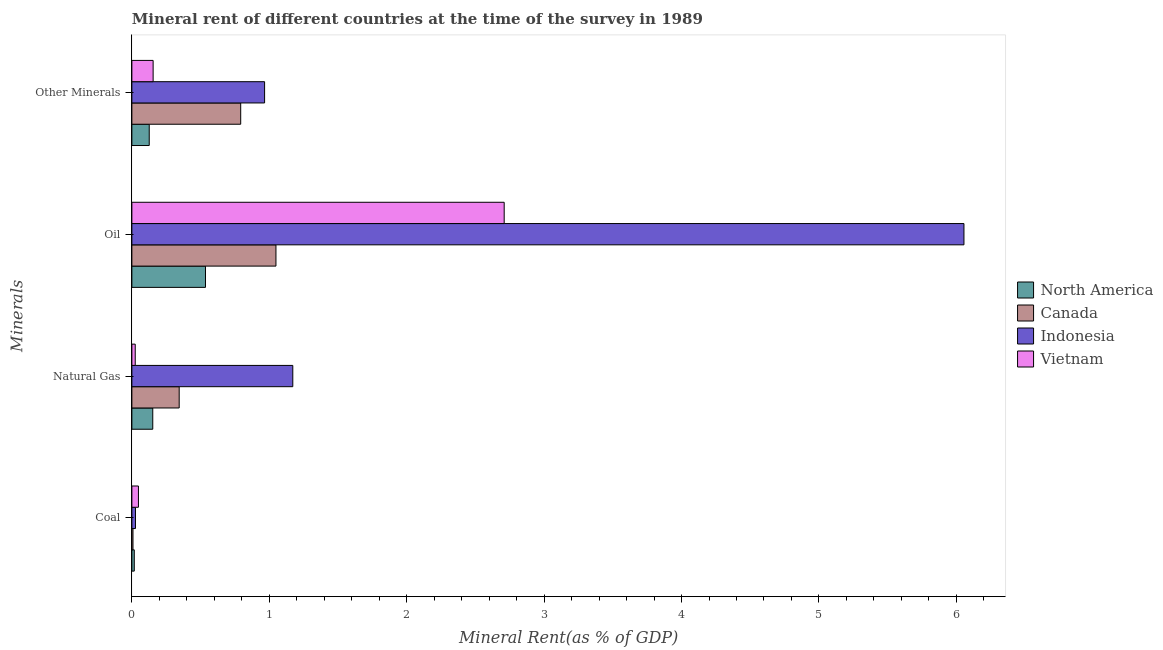Are the number of bars on each tick of the Y-axis equal?
Offer a very short reply. Yes. What is the label of the 2nd group of bars from the top?
Make the answer very short. Oil. What is the natural gas rent in Vietnam?
Provide a short and direct response. 0.02. Across all countries, what is the maximum  rent of other minerals?
Provide a short and direct response. 0.97. Across all countries, what is the minimum oil rent?
Provide a short and direct response. 0.54. What is the total coal rent in the graph?
Keep it short and to the point. 0.1. What is the difference between the  rent of other minerals in Canada and that in North America?
Your response must be concise. 0.67. What is the difference between the natural gas rent in Canada and the coal rent in Indonesia?
Make the answer very short. 0.32. What is the average coal rent per country?
Provide a short and direct response. 0.02. What is the difference between the  rent of other minerals and coal rent in Vietnam?
Provide a succinct answer. 0.11. In how many countries, is the  rent of other minerals greater than 0.6000000000000001 %?
Offer a terse response. 2. What is the ratio of the  rent of other minerals in Indonesia to that in North America?
Provide a succinct answer. 7.64. What is the difference between the highest and the second highest  rent of other minerals?
Offer a very short reply. 0.17. What is the difference between the highest and the lowest natural gas rent?
Provide a succinct answer. 1.15. In how many countries, is the coal rent greater than the average coal rent taken over all countries?
Provide a short and direct response. 2. Is the sum of the natural gas rent in Vietnam and Canada greater than the maximum coal rent across all countries?
Offer a very short reply. Yes. Is it the case that in every country, the sum of the oil rent and natural gas rent is greater than the sum of coal rent and  rent of other minerals?
Offer a very short reply. Yes. What does the 4th bar from the bottom in Natural Gas represents?
Ensure brevity in your answer.  Vietnam. How many bars are there?
Your response must be concise. 16. Are all the bars in the graph horizontal?
Provide a short and direct response. Yes. What is the difference between two consecutive major ticks on the X-axis?
Your answer should be very brief. 1. Does the graph contain grids?
Ensure brevity in your answer.  No. What is the title of the graph?
Give a very brief answer. Mineral rent of different countries at the time of the survey in 1989. What is the label or title of the X-axis?
Provide a short and direct response. Mineral Rent(as % of GDP). What is the label or title of the Y-axis?
Keep it short and to the point. Minerals. What is the Mineral Rent(as % of GDP) of North America in Coal?
Provide a short and direct response. 0.02. What is the Mineral Rent(as % of GDP) of Canada in Coal?
Provide a succinct answer. 0.01. What is the Mineral Rent(as % of GDP) in Indonesia in Coal?
Provide a short and direct response. 0.03. What is the Mineral Rent(as % of GDP) in Vietnam in Coal?
Give a very brief answer. 0.05. What is the Mineral Rent(as % of GDP) in North America in Natural Gas?
Give a very brief answer. 0.15. What is the Mineral Rent(as % of GDP) in Canada in Natural Gas?
Provide a short and direct response. 0.34. What is the Mineral Rent(as % of GDP) of Indonesia in Natural Gas?
Make the answer very short. 1.17. What is the Mineral Rent(as % of GDP) of Vietnam in Natural Gas?
Provide a short and direct response. 0.02. What is the Mineral Rent(as % of GDP) of North America in Oil?
Give a very brief answer. 0.54. What is the Mineral Rent(as % of GDP) in Canada in Oil?
Your answer should be compact. 1.05. What is the Mineral Rent(as % of GDP) in Indonesia in Oil?
Your answer should be very brief. 6.06. What is the Mineral Rent(as % of GDP) in Vietnam in Oil?
Provide a short and direct response. 2.71. What is the Mineral Rent(as % of GDP) of North America in Other Minerals?
Your response must be concise. 0.13. What is the Mineral Rent(as % of GDP) in Canada in Other Minerals?
Provide a succinct answer. 0.79. What is the Mineral Rent(as % of GDP) in Indonesia in Other Minerals?
Offer a terse response. 0.97. What is the Mineral Rent(as % of GDP) in Vietnam in Other Minerals?
Ensure brevity in your answer.  0.15. Across all Minerals, what is the maximum Mineral Rent(as % of GDP) in North America?
Ensure brevity in your answer.  0.54. Across all Minerals, what is the maximum Mineral Rent(as % of GDP) in Canada?
Your response must be concise. 1.05. Across all Minerals, what is the maximum Mineral Rent(as % of GDP) in Indonesia?
Your answer should be very brief. 6.06. Across all Minerals, what is the maximum Mineral Rent(as % of GDP) of Vietnam?
Make the answer very short. 2.71. Across all Minerals, what is the minimum Mineral Rent(as % of GDP) in North America?
Ensure brevity in your answer.  0.02. Across all Minerals, what is the minimum Mineral Rent(as % of GDP) of Canada?
Provide a succinct answer. 0.01. Across all Minerals, what is the minimum Mineral Rent(as % of GDP) of Indonesia?
Provide a succinct answer. 0.03. Across all Minerals, what is the minimum Mineral Rent(as % of GDP) in Vietnam?
Offer a terse response. 0.02. What is the total Mineral Rent(as % of GDP) of North America in the graph?
Offer a very short reply. 0.83. What is the total Mineral Rent(as % of GDP) in Canada in the graph?
Provide a succinct answer. 2.19. What is the total Mineral Rent(as % of GDP) of Indonesia in the graph?
Offer a terse response. 8.22. What is the total Mineral Rent(as % of GDP) in Vietnam in the graph?
Provide a short and direct response. 2.94. What is the difference between the Mineral Rent(as % of GDP) of North America in Coal and that in Natural Gas?
Your answer should be very brief. -0.13. What is the difference between the Mineral Rent(as % of GDP) of Canada in Coal and that in Natural Gas?
Ensure brevity in your answer.  -0.34. What is the difference between the Mineral Rent(as % of GDP) of Indonesia in Coal and that in Natural Gas?
Make the answer very short. -1.14. What is the difference between the Mineral Rent(as % of GDP) of Vietnam in Coal and that in Natural Gas?
Your answer should be very brief. 0.02. What is the difference between the Mineral Rent(as % of GDP) in North America in Coal and that in Oil?
Provide a short and direct response. -0.52. What is the difference between the Mineral Rent(as % of GDP) in Canada in Coal and that in Oil?
Offer a very short reply. -1.04. What is the difference between the Mineral Rent(as % of GDP) of Indonesia in Coal and that in Oil?
Offer a very short reply. -6.03. What is the difference between the Mineral Rent(as % of GDP) in Vietnam in Coal and that in Oil?
Your answer should be compact. -2.66. What is the difference between the Mineral Rent(as % of GDP) in North America in Coal and that in Other Minerals?
Provide a succinct answer. -0.11. What is the difference between the Mineral Rent(as % of GDP) of Canada in Coal and that in Other Minerals?
Give a very brief answer. -0.78. What is the difference between the Mineral Rent(as % of GDP) of Indonesia in Coal and that in Other Minerals?
Keep it short and to the point. -0.94. What is the difference between the Mineral Rent(as % of GDP) in Vietnam in Coal and that in Other Minerals?
Your answer should be very brief. -0.11. What is the difference between the Mineral Rent(as % of GDP) of North America in Natural Gas and that in Oil?
Make the answer very short. -0.38. What is the difference between the Mineral Rent(as % of GDP) of Canada in Natural Gas and that in Oil?
Your answer should be compact. -0.7. What is the difference between the Mineral Rent(as % of GDP) in Indonesia in Natural Gas and that in Oil?
Give a very brief answer. -4.88. What is the difference between the Mineral Rent(as % of GDP) in Vietnam in Natural Gas and that in Oil?
Provide a succinct answer. -2.69. What is the difference between the Mineral Rent(as % of GDP) in North America in Natural Gas and that in Other Minerals?
Make the answer very short. 0.03. What is the difference between the Mineral Rent(as % of GDP) in Canada in Natural Gas and that in Other Minerals?
Provide a short and direct response. -0.45. What is the difference between the Mineral Rent(as % of GDP) in Indonesia in Natural Gas and that in Other Minerals?
Your answer should be very brief. 0.21. What is the difference between the Mineral Rent(as % of GDP) of Vietnam in Natural Gas and that in Other Minerals?
Your answer should be compact. -0.13. What is the difference between the Mineral Rent(as % of GDP) of North America in Oil and that in Other Minerals?
Offer a very short reply. 0.41. What is the difference between the Mineral Rent(as % of GDP) in Canada in Oil and that in Other Minerals?
Give a very brief answer. 0.26. What is the difference between the Mineral Rent(as % of GDP) of Indonesia in Oil and that in Other Minerals?
Offer a terse response. 5.09. What is the difference between the Mineral Rent(as % of GDP) in Vietnam in Oil and that in Other Minerals?
Offer a terse response. 2.55. What is the difference between the Mineral Rent(as % of GDP) in North America in Coal and the Mineral Rent(as % of GDP) in Canada in Natural Gas?
Make the answer very short. -0.33. What is the difference between the Mineral Rent(as % of GDP) in North America in Coal and the Mineral Rent(as % of GDP) in Indonesia in Natural Gas?
Offer a very short reply. -1.15. What is the difference between the Mineral Rent(as % of GDP) in North America in Coal and the Mineral Rent(as % of GDP) in Vietnam in Natural Gas?
Provide a succinct answer. -0.01. What is the difference between the Mineral Rent(as % of GDP) of Canada in Coal and the Mineral Rent(as % of GDP) of Indonesia in Natural Gas?
Your response must be concise. -1.16. What is the difference between the Mineral Rent(as % of GDP) of Canada in Coal and the Mineral Rent(as % of GDP) of Vietnam in Natural Gas?
Offer a terse response. -0.02. What is the difference between the Mineral Rent(as % of GDP) in Indonesia in Coal and the Mineral Rent(as % of GDP) in Vietnam in Natural Gas?
Ensure brevity in your answer.  0. What is the difference between the Mineral Rent(as % of GDP) in North America in Coal and the Mineral Rent(as % of GDP) in Canada in Oil?
Offer a very short reply. -1.03. What is the difference between the Mineral Rent(as % of GDP) of North America in Coal and the Mineral Rent(as % of GDP) of Indonesia in Oil?
Give a very brief answer. -6.04. What is the difference between the Mineral Rent(as % of GDP) in North America in Coal and the Mineral Rent(as % of GDP) in Vietnam in Oil?
Provide a short and direct response. -2.69. What is the difference between the Mineral Rent(as % of GDP) in Canada in Coal and the Mineral Rent(as % of GDP) in Indonesia in Oil?
Offer a very short reply. -6.05. What is the difference between the Mineral Rent(as % of GDP) of Canada in Coal and the Mineral Rent(as % of GDP) of Vietnam in Oil?
Offer a terse response. -2.7. What is the difference between the Mineral Rent(as % of GDP) in Indonesia in Coal and the Mineral Rent(as % of GDP) in Vietnam in Oil?
Your answer should be compact. -2.68. What is the difference between the Mineral Rent(as % of GDP) of North America in Coal and the Mineral Rent(as % of GDP) of Canada in Other Minerals?
Make the answer very short. -0.77. What is the difference between the Mineral Rent(as % of GDP) of North America in Coal and the Mineral Rent(as % of GDP) of Indonesia in Other Minerals?
Give a very brief answer. -0.95. What is the difference between the Mineral Rent(as % of GDP) in North America in Coal and the Mineral Rent(as % of GDP) in Vietnam in Other Minerals?
Ensure brevity in your answer.  -0.14. What is the difference between the Mineral Rent(as % of GDP) of Canada in Coal and the Mineral Rent(as % of GDP) of Indonesia in Other Minerals?
Ensure brevity in your answer.  -0.96. What is the difference between the Mineral Rent(as % of GDP) in Canada in Coal and the Mineral Rent(as % of GDP) in Vietnam in Other Minerals?
Your answer should be very brief. -0.15. What is the difference between the Mineral Rent(as % of GDP) of Indonesia in Coal and the Mineral Rent(as % of GDP) of Vietnam in Other Minerals?
Ensure brevity in your answer.  -0.13. What is the difference between the Mineral Rent(as % of GDP) in North America in Natural Gas and the Mineral Rent(as % of GDP) in Canada in Oil?
Give a very brief answer. -0.9. What is the difference between the Mineral Rent(as % of GDP) of North America in Natural Gas and the Mineral Rent(as % of GDP) of Indonesia in Oil?
Offer a terse response. -5.9. What is the difference between the Mineral Rent(as % of GDP) in North America in Natural Gas and the Mineral Rent(as % of GDP) in Vietnam in Oil?
Make the answer very short. -2.56. What is the difference between the Mineral Rent(as % of GDP) in Canada in Natural Gas and the Mineral Rent(as % of GDP) in Indonesia in Oil?
Your answer should be compact. -5.71. What is the difference between the Mineral Rent(as % of GDP) in Canada in Natural Gas and the Mineral Rent(as % of GDP) in Vietnam in Oil?
Your answer should be very brief. -2.37. What is the difference between the Mineral Rent(as % of GDP) of Indonesia in Natural Gas and the Mineral Rent(as % of GDP) of Vietnam in Oil?
Keep it short and to the point. -1.54. What is the difference between the Mineral Rent(as % of GDP) in North America in Natural Gas and the Mineral Rent(as % of GDP) in Canada in Other Minerals?
Offer a very short reply. -0.64. What is the difference between the Mineral Rent(as % of GDP) of North America in Natural Gas and the Mineral Rent(as % of GDP) of Indonesia in Other Minerals?
Your answer should be compact. -0.81. What is the difference between the Mineral Rent(as % of GDP) of North America in Natural Gas and the Mineral Rent(as % of GDP) of Vietnam in Other Minerals?
Keep it short and to the point. -0. What is the difference between the Mineral Rent(as % of GDP) in Canada in Natural Gas and the Mineral Rent(as % of GDP) in Indonesia in Other Minerals?
Offer a terse response. -0.62. What is the difference between the Mineral Rent(as % of GDP) of Canada in Natural Gas and the Mineral Rent(as % of GDP) of Vietnam in Other Minerals?
Keep it short and to the point. 0.19. What is the difference between the Mineral Rent(as % of GDP) in Indonesia in Natural Gas and the Mineral Rent(as % of GDP) in Vietnam in Other Minerals?
Offer a terse response. 1.02. What is the difference between the Mineral Rent(as % of GDP) in North America in Oil and the Mineral Rent(as % of GDP) in Canada in Other Minerals?
Offer a terse response. -0.26. What is the difference between the Mineral Rent(as % of GDP) of North America in Oil and the Mineral Rent(as % of GDP) of Indonesia in Other Minerals?
Your response must be concise. -0.43. What is the difference between the Mineral Rent(as % of GDP) in North America in Oil and the Mineral Rent(as % of GDP) in Vietnam in Other Minerals?
Your response must be concise. 0.38. What is the difference between the Mineral Rent(as % of GDP) of Canada in Oil and the Mineral Rent(as % of GDP) of Indonesia in Other Minerals?
Ensure brevity in your answer.  0.08. What is the difference between the Mineral Rent(as % of GDP) in Canada in Oil and the Mineral Rent(as % of GDP) in Vietnam in Other Minerals?
Give a very brief answer. 0.89. What is the difference between the Mineral Rent(as % of GDP) in Indonesia in Oil and the Mineral Rent(as % of GDP) in Vietnam in Other Minerals?
Your answer should be compact. 5.9. What is the average Mineral Rent(as % of GDP) of North America per Minerals?
Provide a succinct answer. 0.21. What is the average Mineral Rent(as % of GDP) of Canada per Minerals?
Make the answer very short. 0.55. What is the average Mineral Rent(as % of GDP) in Indonesia per Minerals?
Give a very brief answer. 2.05. What is the average Mineral Rent(as % of GDP) in Vietnam per Minerals?
Offer a terse response. 0.73. What is the difference between the Mineral Rent(as % of GDP) of North America and Mineral Rent(as % of GDP) of Canada in Coal?
Keep it short and to the point. 0.01. What is the difference between the Mineral Rent(as % of GDP) in North America and Mineral Rent(as % of GDP) in Indonesia in Coal?
Your answer should be very brief. -0.01. What is the difference between the Mineral Rent(as % of GDP) in North America and Mineral Rent(as % of GDP) in Vietnam in Coal?
Make the answer very short. -0.03. What is the difference between the Mineral Rent(as % of GDP) in Canada and Mineral Rent(as % of GDP) in Indonesia in Coal?
Make the answer very short. -0.02. What is the difference between the Mineral Rent(as % of GDP) in Canada and Mineral Rent(as % of GDP) in Vietnam in Coal?
Ensure brevity in your answer.  -0.04. What is the difference between the Mineral Rent(as % of GDP) in Indonesia and Mineral Rent(as % of GDP) in Vietnam in Coal?
Provide a short and direct response. -0.02. What is the difference between the Mineral Rent(as % of GDP) in North America and Mineral Rent(as % of GDP) in Canada in Natural Gas?
Give a very brief answer. -0.19. What is the difference between the Mineral Rent(as % of GDP) of North America and Mineral Rent(as % of GDP) of Indonesia in Natural Gas?
Your answer should be very brief. -1.02. What is the difference between the Mineral Rent(as % of GDP) in North America and Mineral Rent(as % of GDP) in Vietnam in Natural Gas?
Ensure brevity in your answer.  0.13. What is the difference between the Mineral Rent(as % of GDP) in Canada and Mineral Rent(as % of GDP) in Indonesia in Natural Gas?
Your answer should be very brief. -0.83. What is the difference between the Mineral Rent(as % of GDP) of Canada and Mineral Rent(as % of GDP) of Vietnam in Natural Gas?
Your answer should be very brief. 0.32. What is the difference between the Mineral Rent(as % of GDP) of Indonesia and Mineral Rent(as % of GDP) of Vietnam in Natural Gas?
Keep it short and to the point. 1.15. What is the difference between the Mineral Rent(as % of GDP) in North America and Mineral Rent(as % of GDP) in Canada in Oil?
Ensure brevity in your answer.  -0.51. What is the difference between the Mineral Rent(as % of GDP) in North America and Mineral Rent(as % of GDP) in Indonesia in Oil?
Ensure brevity in your answer.  -5.52. What is the difference between the Mineral Rent(as % of GDP) in North America and Mineral Rent(as % of GDP) in Vietnam in Oil?
Your answer should be compact. -2.17. What is the difference between the Mineral Rent(as % of GDP) of Canada and Mineral Rent(as % of GDP) of Indonesia in Oil?
Your answer should be very brief. -5.01. What is the difference between the Mineral Rent(as % of GDP) in Canada and Mineral Rent(as % of GDP) in Vietnam in Oil?
Your answer should be compact. -1.66. What is the difference between the Mineral Rent(as % of GDP) in Indonesia and Mineral Rent(as % of GDP) in Vietnam in Oil?
Keep it short and to the point. 3.35. What is the difference between the Mineral Rent(as % of GDP) in North America and Mineral Rent(as % of GDP) in Canada in Other Minerals?
Offer a terse response. -0.67. What is the difference between the Mineral Rent(as % of GDP) in North America and Mineral Rent(as % of GDP) in Indonesia in Other Minerals?
Make the answer very short. -0.84. What is the difference between the Mineral Rent(as % of GDP) in North America and Mineral Rent(as % of GDP) in Vietnam in Other Minerals?
Give a very brief answer. -0.03. What is the difference between the Mineral Rent(as % of GDP) of Canada and Mineral Rent(as % of GDP) of Indonesia in Other Minerals?
Make the answer very short. -0.17. What is the difference between the Mineral Rent(as % of GDP) in Canada and Mineral Rent(as % of GDP) in Vietnam in Other Minerals?
Keep it short and to the point. 0.64. What is the difference between the Mineral Rent(as % of GDP) of Indonesia and Mineral Rent(as % of GDP) of Vietnam in Other Minerals?
Offer a very short reply. 0.81. What is the ratio of the Mineral Rent(as % of GDP) of North America in Coal to that in Natural Gas?
Your response must be concise. 0.12. What is the ratio of the Mineral Rent(as % of GDP) of Canada in Coal to that in Natural Gas?
Your answer should be compact. 0.02. What is the ratio of the Mineral Rent(as % of GDP) of Indonesia in Coal to that in Natural Gas?
Offer a very short reply. 0.02. What is the ratio of the Mineral Rent(as % of GDP) in Vietnam in Coal to that in Natural Gas?
Make the answer very short. 1.95. What is the ratio of the Mineral Rent(as % of GDP) in North America in Coal to that in Oil?
Provide a succinct answer. 0.03. What is the ratio of the Mineral Rent(as % of GDP) of Canada in Coal to that in Oil?
Provide a succinct answer. 0.01. What is the ratio of the Mineral Rent(as % of GDP) in Indonesia in Coal to that in Oil?
Your answer should be compact. 0. What is the ratio of the Mineral Rent(as % of GDP) in Vietnam in Coal to that in Oil?
Your response must be concise. 0.02. What is the ratio of the Mineral Rent(as % of GDP) of North America in Coal to that in Other Minerals?
Your answer should be very brief. 0.14. What is the ratio of the Mineral Rent(as % of GDP) in Canada in Coal to that in Other Minerals?
Your answer should be very brief. 0.01. What is the ratio of the Mineral Rent(as % of GDP) in Indonesia in Coal to that in Other Minerals?
Provide a short and direct response. 0.03. What is the ratio of the Mineral Rent(as % of GDP) in Vietnam in Coal to that in Other Minerals?
Provide a succinct answer. 0.31. What is the ratio of the Mineral Rent(as % of GDP) of North America in Natural Gas to that in Oil?
Provide a short and direct response. 0.28. What is the ratio of the Mineral Rent(as % of GDP) of Canada in Natural Gas to that in Oil?
Make the answer very short. 0.33. What is the ratio of the Mineral Rent(as % of GDP) in Indonesia in Natural Gas to that in Oil?
Give a very brief answer. 0.19. What is the ratio of the Mineral Rent(as % of GDP) of Vietnam in Natural Gas to that in Oil?
Your answer should be compact. 0.01. What is the ratio of the Mineral Rent(as % of GDP) of North America in Natural Gas to that in Other Minerals?
Keep it short and to the point. 1.2. What is the ratio of the Mineral Rent(as % of GDP) of Canada in Natural Gas to that in Other Minerals?
Your answer should be compact. 0.43. What is the ratio of the Mineral Rent(as % of GDP) of Indonesia in Natural Gas to that in Other Minerals?
Provide a succinct answer. 1.21. What is the ratio of the Mineral Rent(as % of GDP) in Vietnam in Natural Gas to that in Other Minerals?
Your answer should be very brief. 0.16. What is the ratio of the Mineral Rent(as % of GDP) of North America in Oil to that in Other Minerals?
Ensure brevity in your answer.  4.24. What is the ratio of the Mineral Rent(as % of GDP) of Canada in Oil to that in Other Minerals?
Your answer should be compact. 1.32. What is the ratio of the Mineral Rent(as % of GDP) of Indonesia in Oil to that in Other Minerals?
Ensure brevity in your answer.  6.27. What is the ratio of the Mineral Rent(as % of GDP) of Vietnam in Oil to that in Other Minerals?
Make the answer very short. 17.52. What is the difference between the highest and the second highest Mineral Rent(as % of GDP) in North America?
Provide a short and direct response. 0.38. What is the difference between the highest and the second highest Mineral Rent(as % of GDP) of Canada?
Offer a very short reply. 0.26. What is the difference between the highest and the second highest Mineral Rent(as % of GDP) of Indonesia?
Keep it short and to the point. 4.88. What is the difference between the highest and the second highest Mineral Rent(as % of GDP) in Vietnam?
Offer a very short reply. 2.55. What is the difference between the highest and the lowest Mineral Rent(as % of GDP) in North America?
Ensure brevity in your answer.  0.52. What is the difference between the highest and the lowest Mineral Rent(as % of GDP) in Canada?
Keep it short and to the point. 1.04. What is the difference between the highest and the lowest Mineral Rent(as % of GDP) in Indonesia?
Make the answer very short. 6.03. What is the difference between the highest and the lowest Mineral Rent(as % of GDP) of Vietnam?
Your response must be concise. 2.69. 